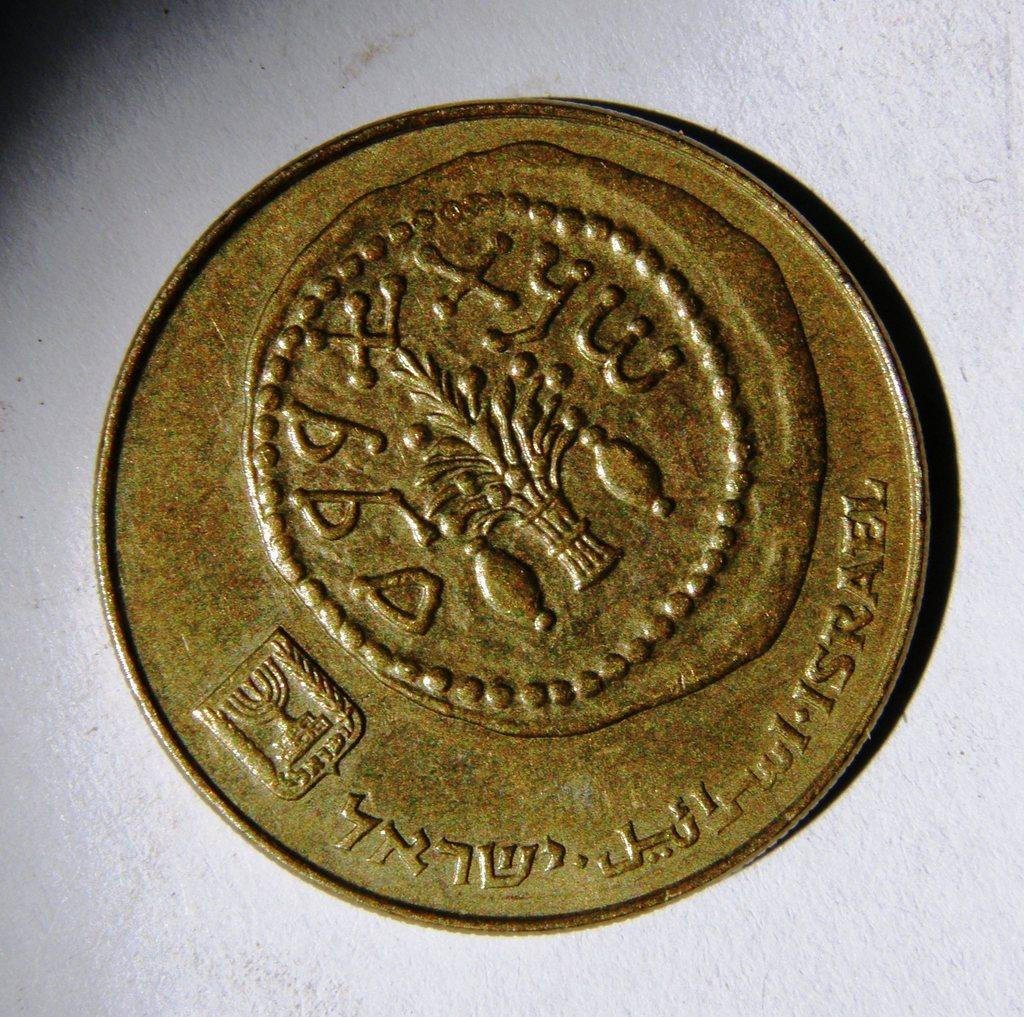Provide a one-sentence caption for the provided image. An old looking coin with the word Israel visible at the bottom left. 